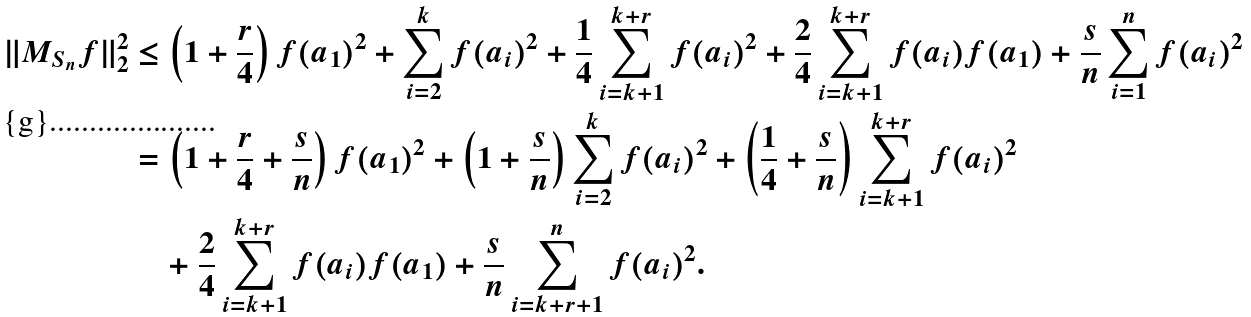Convert formula to latex. <formula><loc_0><loc_0><loc_500><loc_500>\| M _ { S _ { n } } f \| ^ { 2 } _ { 2 } & \leq \left ( 1 + \frac { r } { 4 } \right ) f ( a _ { 1 } ) ^ { 2 } + \sum _ { i = 2 } ^ { k } f ( a _ { i } ) ^ { 2 } + \frac { 1 } { 4 } \sum _ { i = k + 1 } ^ { k + r } f ( a _ { i } ) ^ { 2 } + \frac { 2 } { 4 } \sum _ { i = k + 1 } ^ { k + r } f ( a _ { i } ) f ( a _ { 1 } ) + \frac { s } { n } \sum _ { i = 1 } ^ { n } f ( a _ { i } ) ^ { 2 } \\ & = \left ( 1 + \frac { r } { 4 } + \frac { s } { n } \right ) f ( a _ { 1 } ) ^ { 2 } + \left ( 1 + \frac { s } { n } \right ) \sum _ { i = 2 } ^ { k } f ( a _ { i } ) ^ { 2 } + \left ( \frac { 1 } { 4 } + \frac { s } { n } \right ) \sum _ { i = k + 1 } ^ { k + r } f ( a _ { i } ) ^ { 2 } \\ & \quad + \frac { 2 } { 4 } \sum _ { i = k + 1 } ^ { k + r } f ( a _ { i } ) f ( a _ { 1 } ) + \frac { s } { n } \sum _ { i = k + r + 1 } ^ { n } f ( a _ { i } ) ^ { 2 } .</formula> 